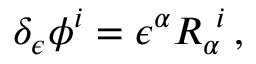Convert formula to latex. <formula><loc_0><loc_0><loc_500><loc_500>\delta _ { \epsilon } \phi ^ { i } = \epsilon ^ { \alpha } R _ { \alpha } ^ { \ i } \, ,</formula> 